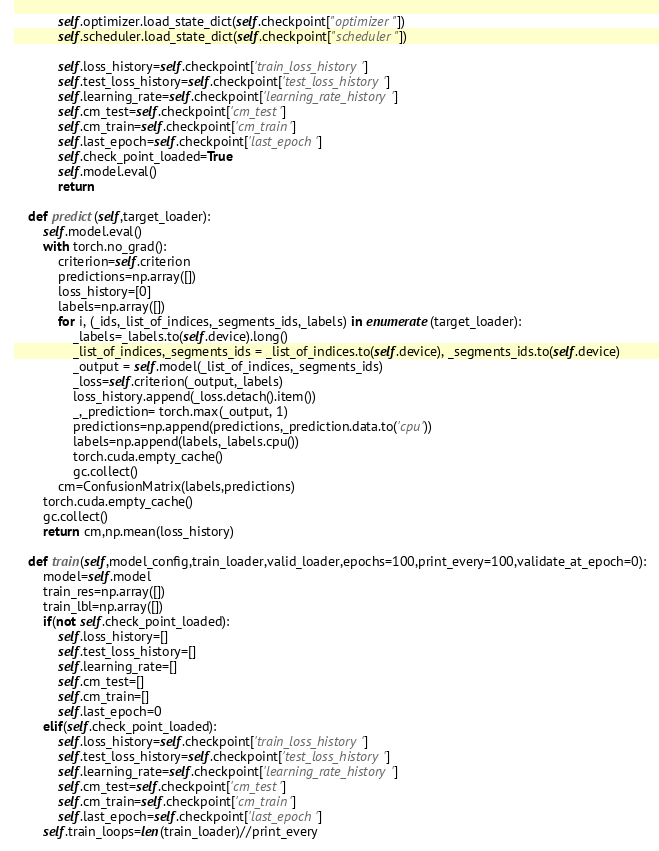Convert code to text. <code><loc_0><loc_0><loc_500><loc_500><_Python_>            self.optimizer.load_state_dict(self.checkpoint["optimizer"])
            self.scheduler.load_state_dict(self.checkpoint["scheduler"])
            
            self.loss_history=self.checkpoint['train_loss_history']
            self.test_loss_history=self.checkpoint['test_loss_history']
            self.learning_rate=self.checkpoint['learning_rate_history']
            self.cm_test=self.checkpoint['cm_test']
            self.cm_train=self.checkpoint['cm_train']
            self.last_epoch=self.checkpoint['last_epoch']
            self.check_point_loaded=True
            self.model.eval()
            return 

    def predict(self,target_loader):
        self.model.eval()
        with torch.no_grad():
            criterion=self.criterion
            predictions=np.array([])
            loss_history=[0]
            labels=np.array([])
            for i, (_ids,_list_of_indices,_segments_ids,_labels) in enumerate(target_loader):
                _labels=_labels.to(self.device).long()
                _list_of_indices,_segments_ids = _list_of_indices.to(self.device), _segments_ids.to(self.device)
                _output = self.model(_list_of_indices,_segments_ids)
                _loss=self.criterion(_output,_labels)
                loss_history.append(_loss.detach().item())
                _,_prediction= torch.max(_output, 1)
                predictions=np.append(predictions,_prediction.data.to('cpu'))
                labels=np.append(labels,_labels.cpu())
                torch.cuda.empty_cache()
                gc.collect()
            cm=ConfusionMatrix(labels,predictions)
        torch.cuda.empty_cache()
        gc.collect()
        return cm,np.mean(loss_history)

    def train(self,model_config,train_loader,valid_loader,epochs=100,print_every=100,validate_at_epoch=0):
        model=self.model
        train_res=np.array([])
        train_lbl=np.array([])
        if(not self.check_point_loaded):
            self.loss_history=[]
            self.test_loss_history=[]
            self.learning_rate=[]
            self.cm_test=[]
            self.cm_train=[]
            self.last_epoch=0
        elif(self.check_point_loaded):
            self.loss_history=self.checkpoint['train_loss_history']
            self.test_loss_history=self.checkpoint['test_loss_history']
            self.learning_rate=self.checkpoint['learning_rate_history']
            self.cm_test=self.checkpoint['cm_test']
            self.cm_train=self.checkpoint['cm_train']
            self.last_epoch=self.checkpoint['last_epoch']
        self.train_loops=len(train_loader)//print_every</code> 